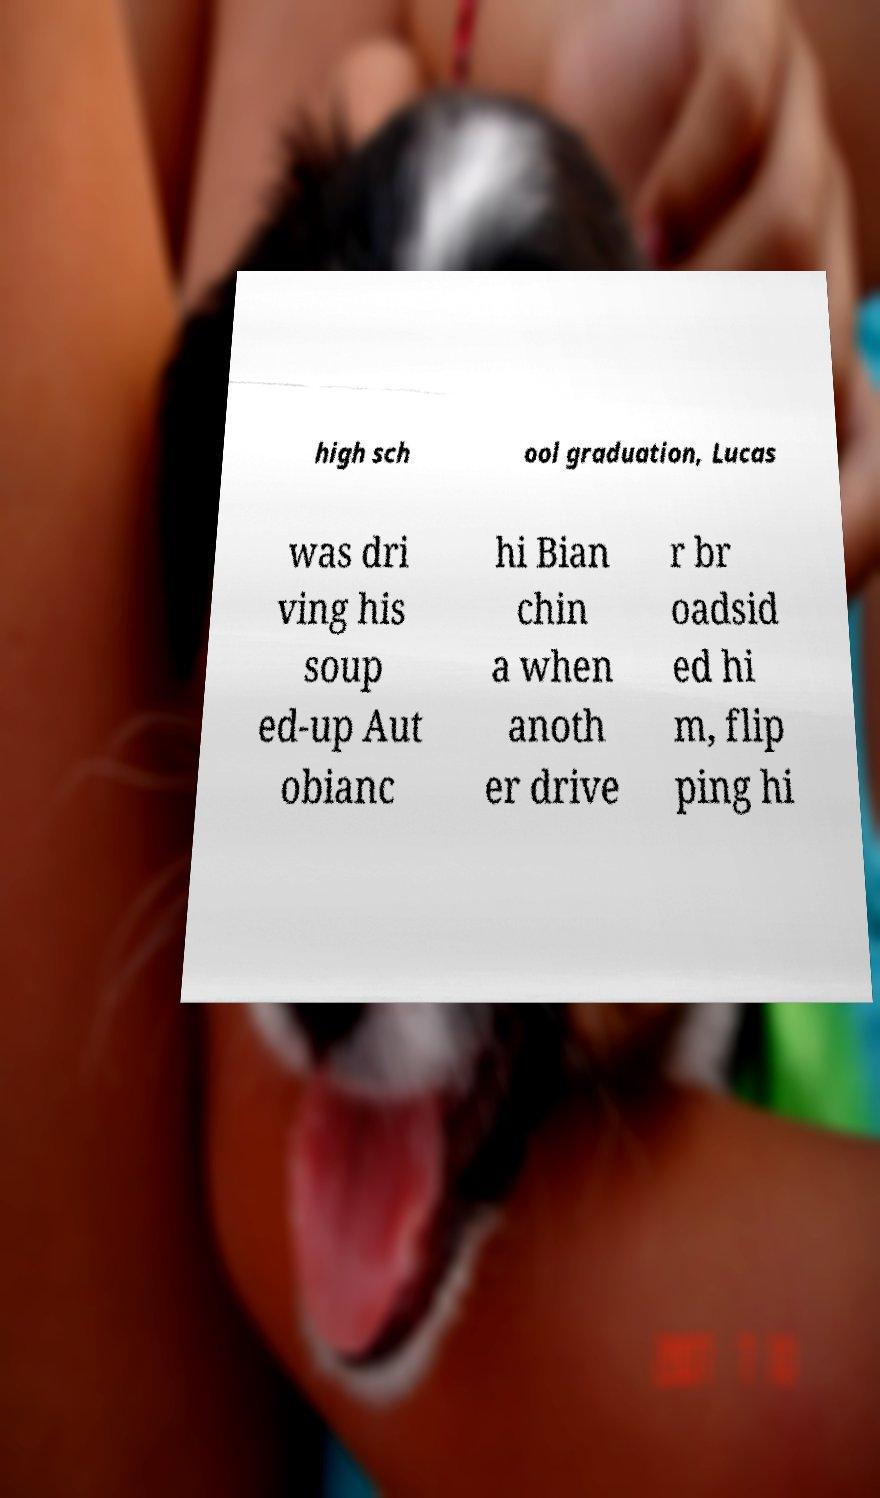Please identify and transcribe the text found in this image. high sch ool graduation, Lucas was dri ving his soup ed-up Aut obianc hi Bian chin a when anoth er drive r br oadsid ed hi m, flip ping hi 